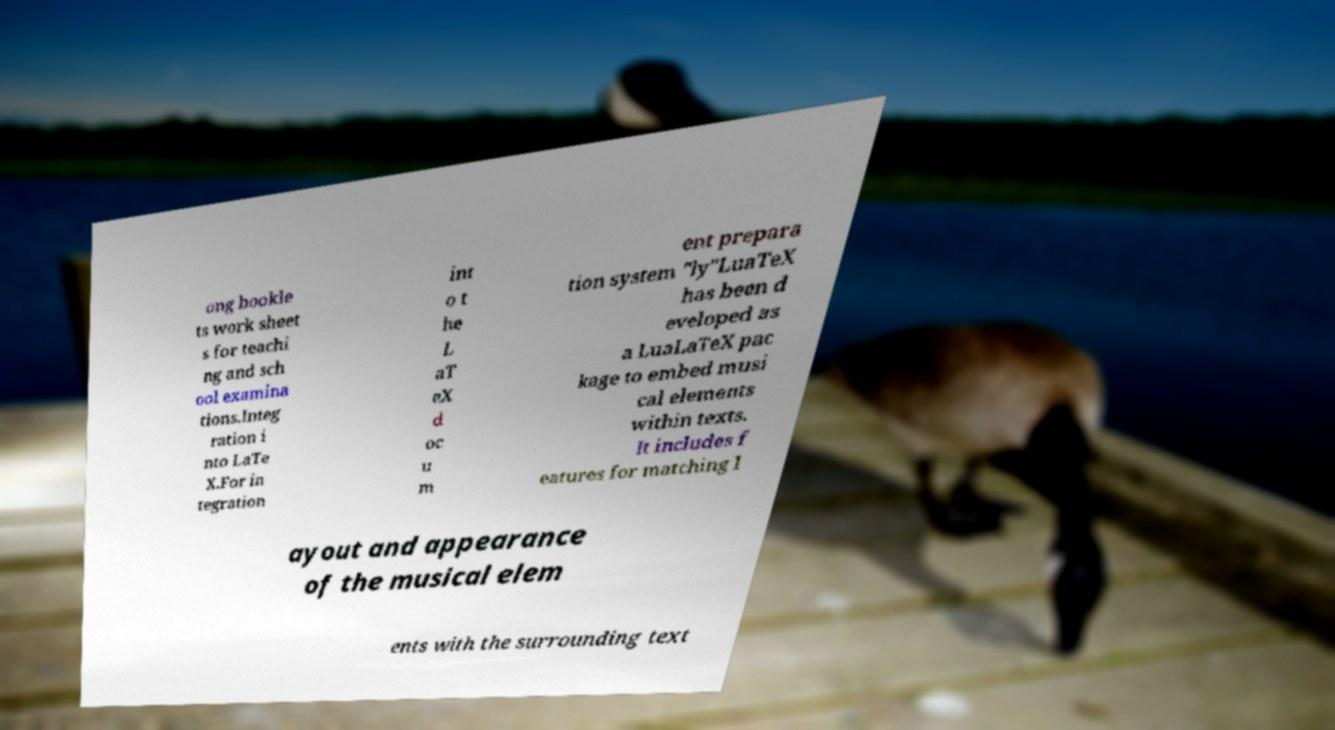Could you assist in decoding the text presented in this image and type it out clearly? ong bookle ts work sheet s for teachi ng and sch ool examina tions.Integ ration i nto LaTe X.For in tegration int o t he L aT eX d oc u m ent prepara tion system "ly"LuaTeX has been d eveloped as a LuaLaTeX pac kage to embed musi cal elements within texts. It includes f eatures for matching l ayout and appearance of the musical elem ents with the surrounding text 